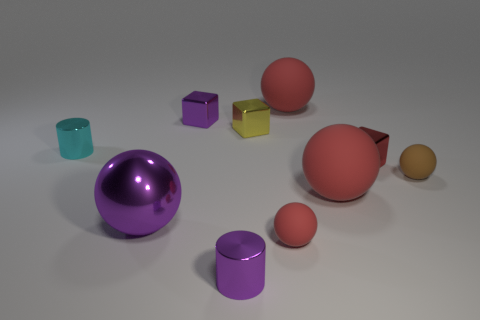Do the cyan object and the purple thing behind the tiny red metal object have the same size?
Offer a terse response. Yes. What is the color of the big matte thing that is in front of the large sphere behind the purple cube?
Your answer should be compact. Red. What number of other objects are the same color as the large metal ball?
Ensure brevity in your answer.  2. How big is the brown thing?
Your answer should be very brief. Small. Are there more cyan metal objects that are right of the big purple ball than tiny brown rubber things that are right of the small cyan thing?
Offer a terse response. No. There is a small cube that is in front of the small yellow object; what number of small metallic cubes are behind it?
Your answer should be very brief. 2. Do the purple shiny object that is behind the small red metallic cube and the tiny yellow object have the same shape?
Keep it short and to the point. Yes. There is another small thing that is the same shape as the cyan thing; what is it made of?
Give a very brief answer. Metal. How many cyan objects are the same size as the purple cylinder?
Your answer should be very brief. 1. There is a small thing that is to the left of the tiny red rubber thing and in front of the tiny brown matte object; what is its color?
Provide a succinct answer. Purple. 